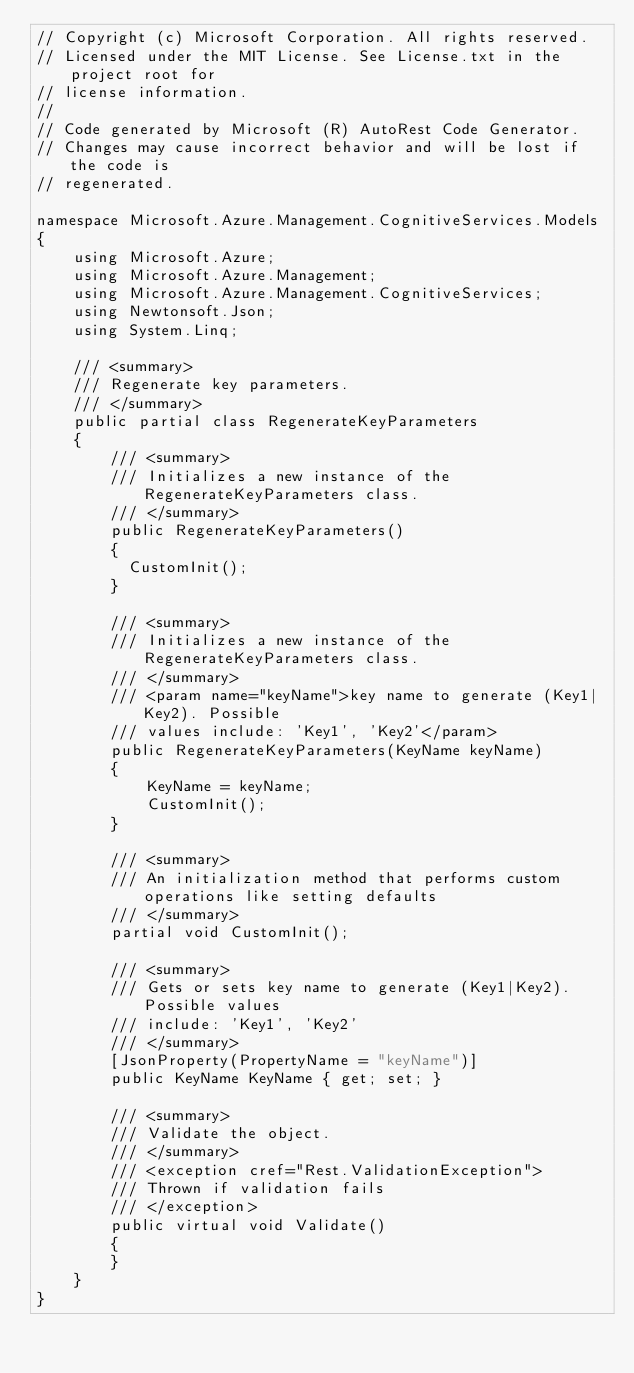<code> <loc_0><loc_0><loc_500><loc_500><_C#_>// Copyright (c) Microsoft Corporation. All rights reserved.
// Licensed under the MIT License. See License.txt in the project root for
// license information.
//
// Code generated by Microsoft (R) AutoRest Code Generator.
// Changes may cause incorrect behavior and will be lost if the code is
// regenerated.

namespace Microsoft.Azure.Management.CognitiveServices.Models
{
    using Microsoft.Azure;
    using Microsoft.Azure.Management;
    using Microsoft.Azure.Management.CognitiveServices;
    using Newtonsoft.Json;
    using System.Linq;

    /// <summary>
    /// Regenerate key parameters.
    /// </summary>
    public partial class RegenerateKeyParameters
    {
        /// <summary>
        /// Initializes a new instance of the RegenerateKeyParameters class.
        /// </summary>
        public RegenerateKeyParameters()
        {
          CustomInit();
        }

        /// <summary>
        /// Initializes a new instance of the RegenerateKeyParameters class.
        /// </summary>
        /// <param name="keyName">key name to generate (Key1|Key2). Possible
        /// values include: 'Key1', 'Key2'</param>
        public RegenerateKeyParameters(KeyName keyName)
        {
            KeyName = keyName;
            CustomInit();
        }

        /// <summary>
        /// An initialization method that performs custom operations like setting defaults
        /// </summary>
        partial void CustomInit();

        /// <summary>
        /// Gets or sets key name to generate (Key1|Key2). Possible values
        /// include: 'Key1', 'Key2'
        /// </summary>
        [JsonProperty(PropertyName = "keyName")]
        public KeyName KeyName { get; set; }

        /// <summary>
        /// Validate the object.
        /// </summary>
        /// <exception cref="Rest.ValidationException">
        /// Thrown if validation fails
        /// </exception>
        public virtual void Validate()
        {
        }
    }
}
</code> 